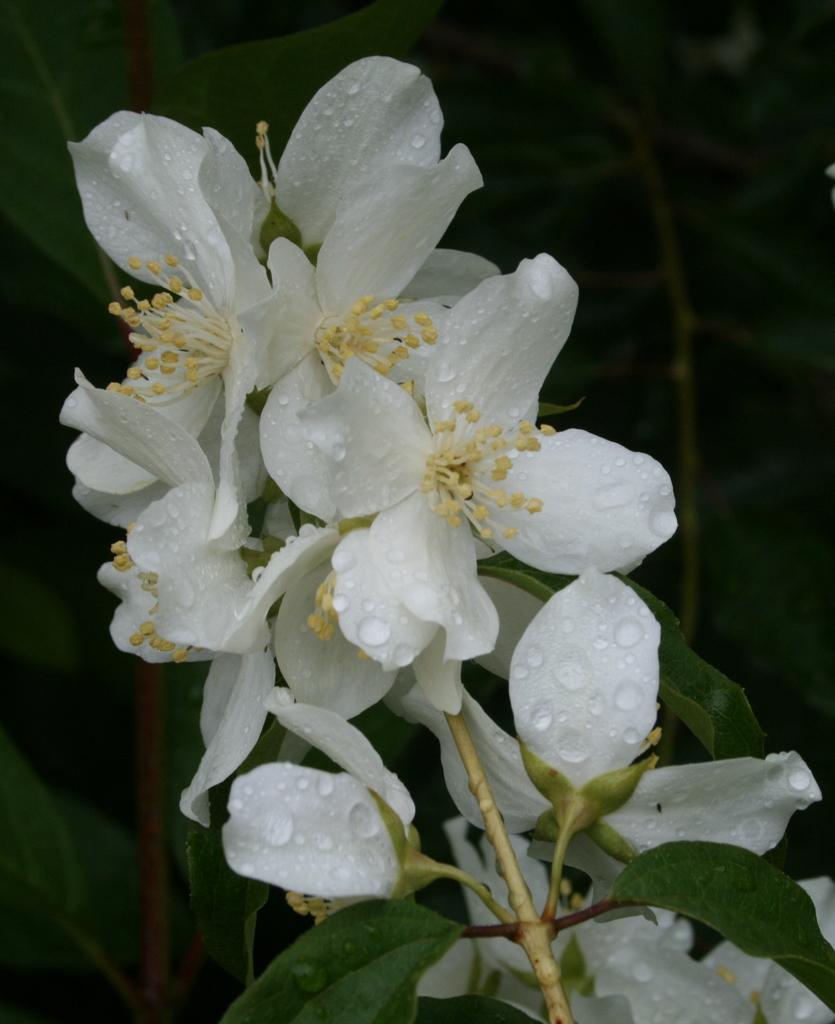Could you give a brief overview of what you see in this image? In this picture I can see there is a stem with white flowers and it has white petals with water droplets and the backdrop there are plants, it is bit dark. 